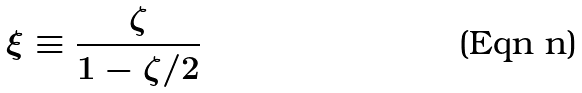<formula> <loc_0><loc_0><loc_500><loc_500>\xi \equiv \frac { \zeta } { 1 - \zeta / 2 }</formula> 